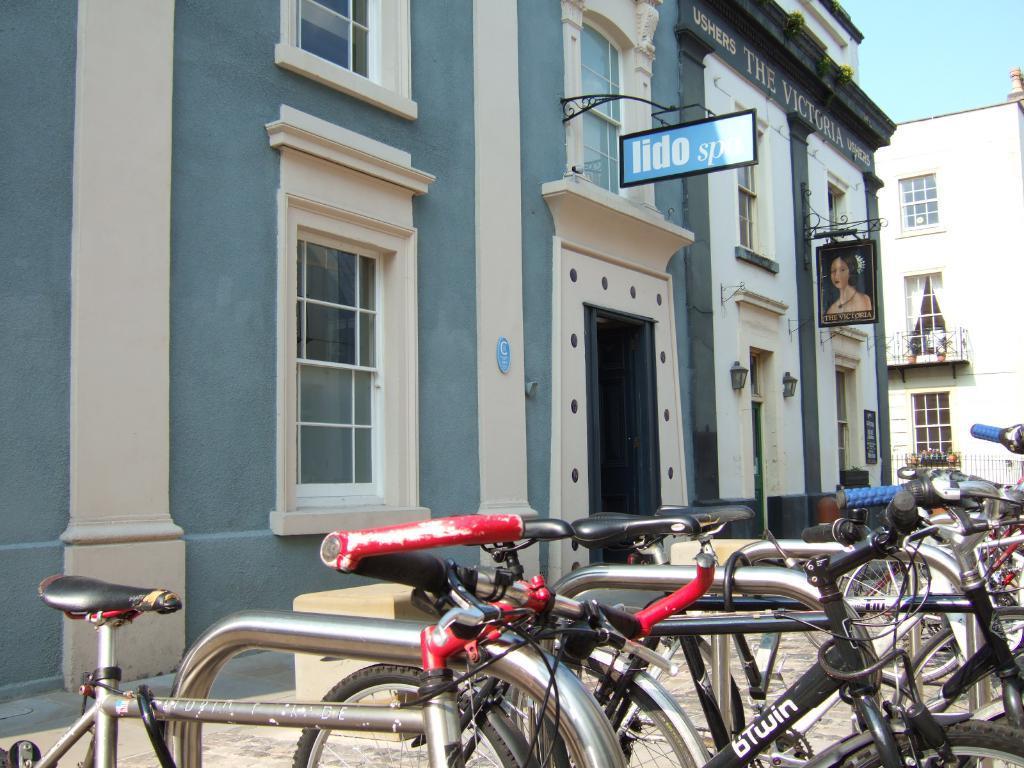Please provide a concise description of this image. In this image I can see number of bicycles which are black, white, blue and red in color are on the sidewalk. In the background I can see few buildings, few boards, few windows and the sky. 